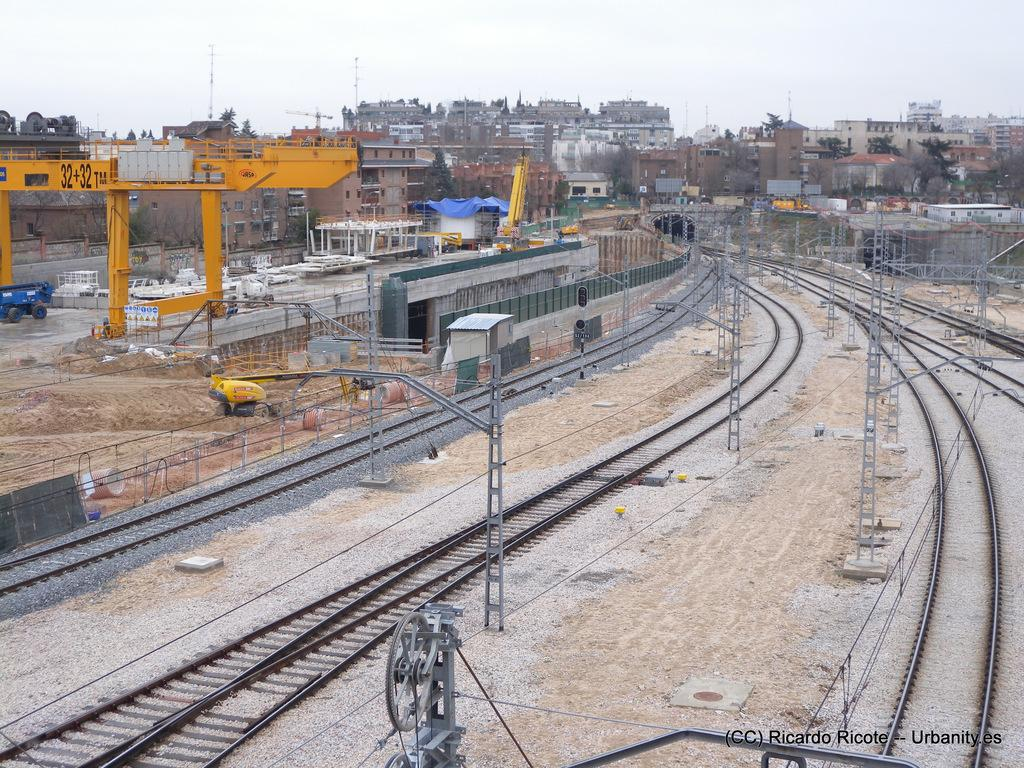<image>
Write a terse but informative summary of the picture. Ricardo Ricote took this photograph of empty train tracks. 